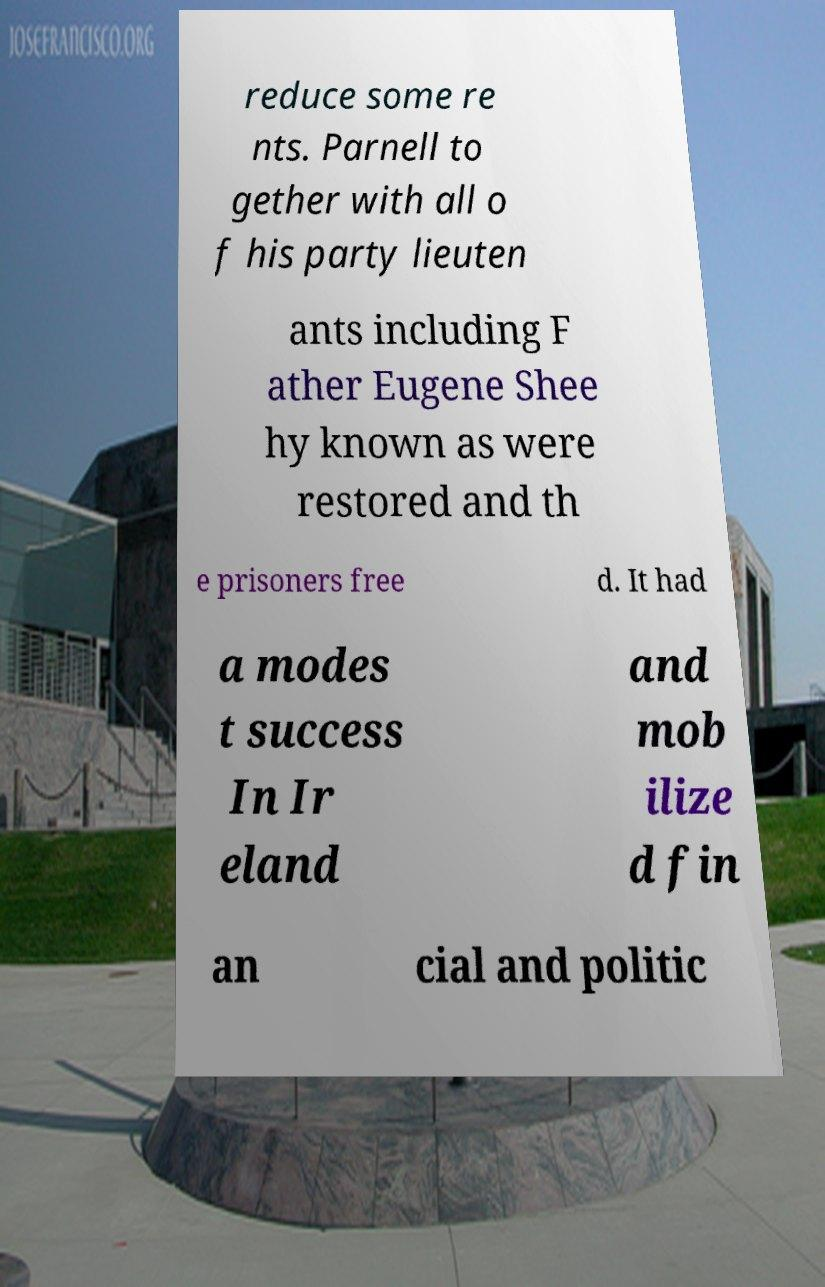For documentation purposes, I need the text within this image transcribed. Could you provide that? reduce some re nts. Parnell to gether with all o f his party lieuten ants including F ather Eugene Shee hy known as were restored and th e prisoners free d. It had a modes t success In Ir eland and mob ilize d fin an cial and politic 